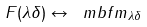Convert formula to latex. <formula><loc_0><loc_0><loc_500><loc_500>F ( \lambda \delta ) \leftrightarrow \ m b f m _ { \lambda \delta }</formula> 